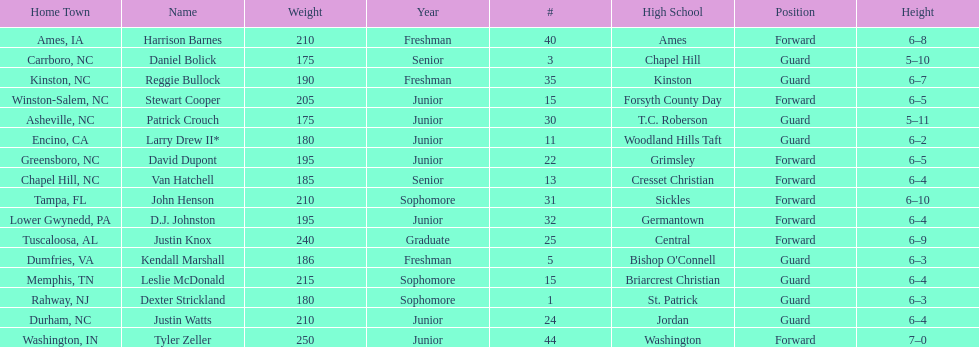What is the number of players with a weight over 200? 7. 